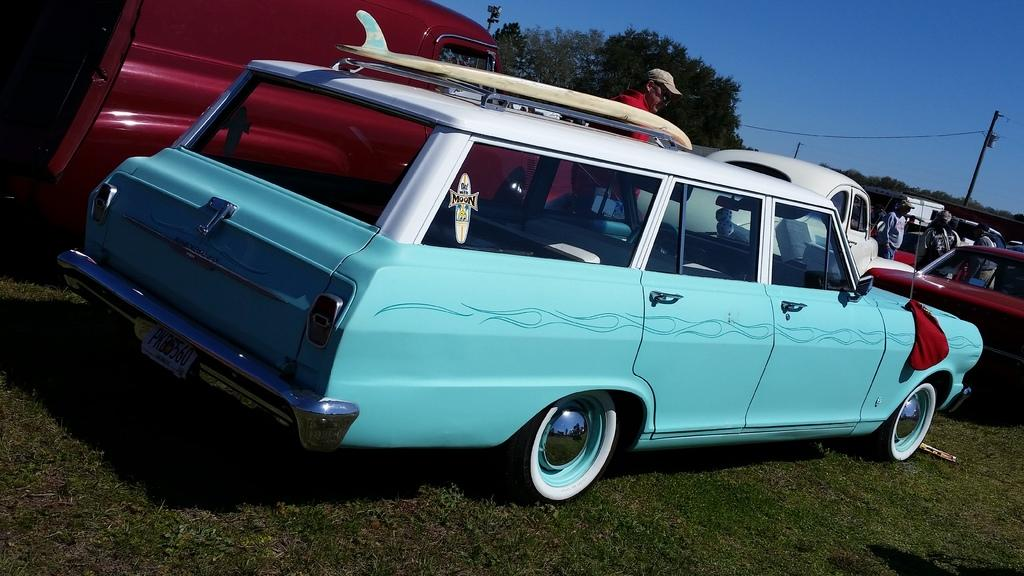What types of objects can be seen in the image? There are vehicles in the image. Can you describe the people in the image? There is a group of people standing in the image. What structures are present in the image? There are poles in the image. What type of natural elements can be seen in the image? There are trees in the image. What is visible in the background of the image? The sky is visible in the background of the image. What type of health advice is being given to the family in the image? There is no indication of health advice or a family in the image; it features vehicles, a group of people, poles, trees, and the sky. How many boats are visible in the image? There are no boats present in the image. 